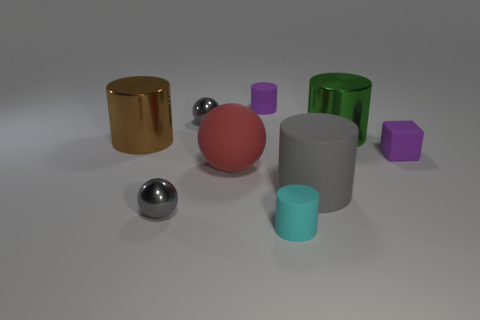Can you describe the difference in texture between the objects? Sure, the objects exhibit a variety of textures. The golden cylinder appears polished and reflective, similar to the smaller silver spheres, depicting a metallic finish. The matte sphere has a more diffuse reflection, indicating a non-glossy surface. The large green object has a smoother, reflective metallic finish, while the purple hexagonal prisms seem to have a slightly more matte texture. 